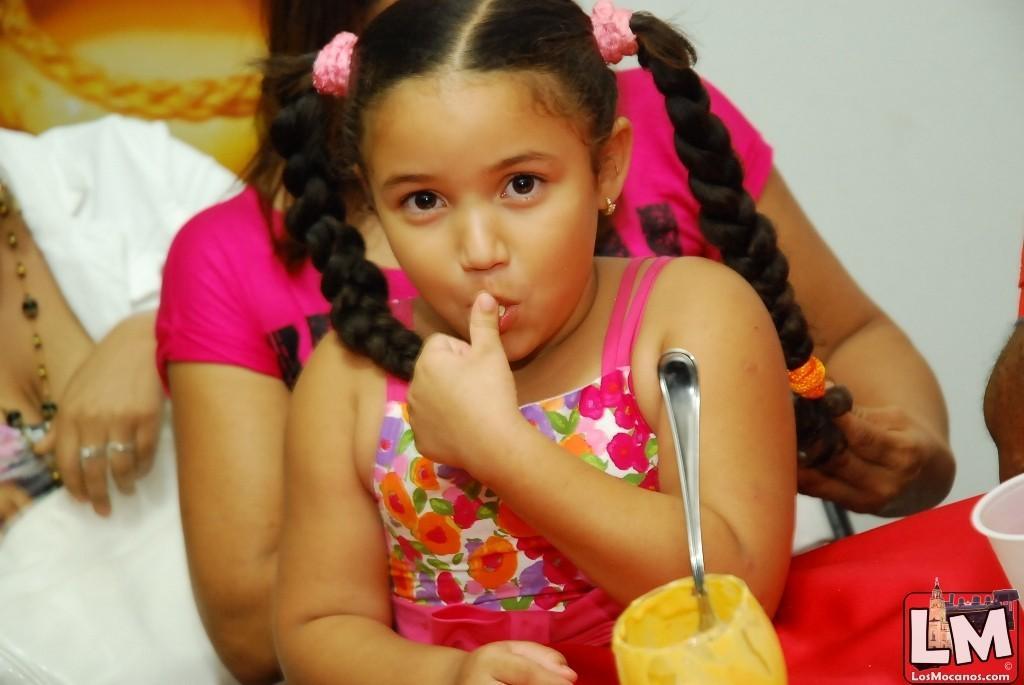Please provide a concise description of this image. In this image I can see a baby wearing a pink color skirt and in front of her I can see glass contain a spoon and back side of her I can see two persons and in the top right I can see the wall. 